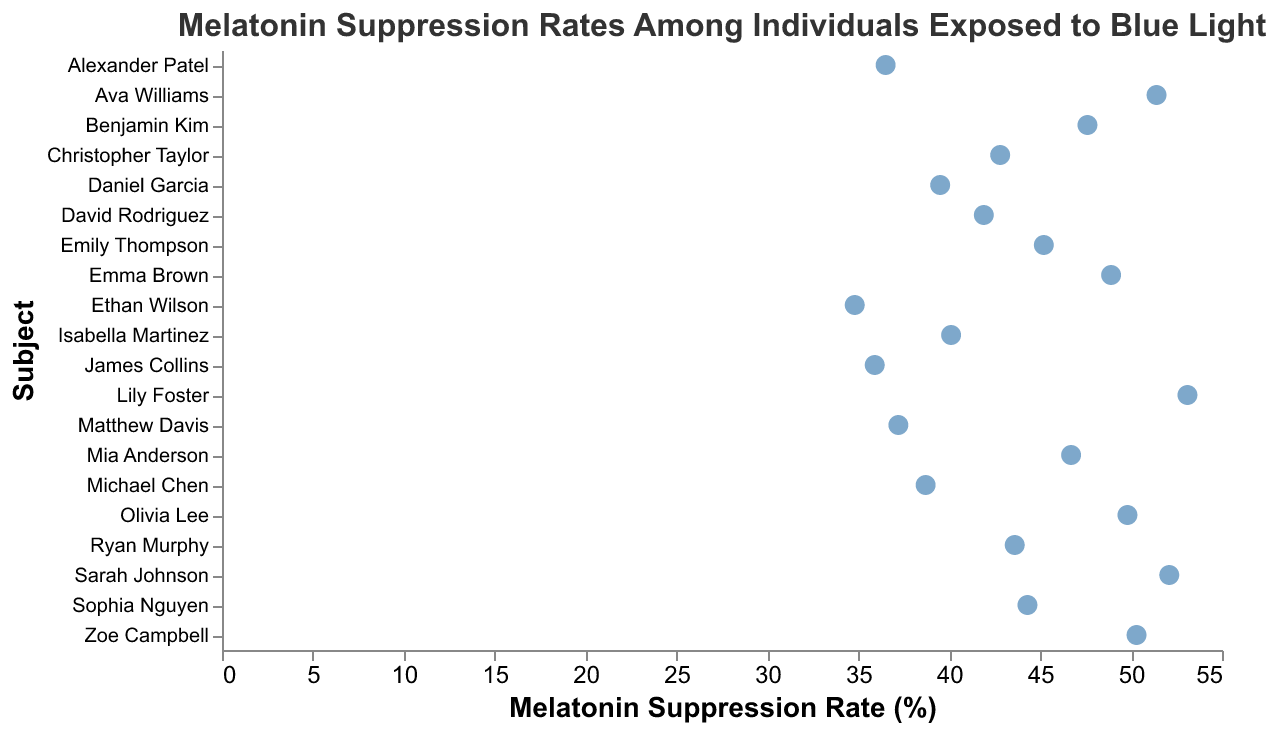Which subject has the highest melatonin suppression rate? Locate the subject with the point farthest to the right on the x-axis. That point corresponds to Lily Foster, with a melatonin suppression rate of 53.1.
Answer: Lily Foster Which subject has the lowest melatonin suppression rate? Locate the subject with the point farthest to the left on the x-axis. That point corresponds to Ethan Wilson, with a melatonin suppression rate of 34.8.
Answer: Ethan Wilson How many subjects are included in the plot? Count each unique point (data entry) on the plot. There are 20 subjects listed in the provided data, and each has a unique data point on the plot.
Answer: 20 What is the average melatonin suppression rate among the subjects? Sum up all the melatonin suppression rates and divide by the number of subjects. The total sum is (45.2 + 38.7 + 52.1 + 41.9 + 49.8 + 36.5 + 44.3 + 47.6 + 40.1 + 34.8 + 51.4 + 39.5 + 46.7 + 42.8 + 48.9 + 37.2 + 50.3 + 43.6 + 53.1 + 35.9) = 880.4. There are 20 subjects, so the average is 880.4 / 20 = 44.02.
Answer: 44.02 What is the range of melatonin suppression rates in the plot? Subtract the lowest suppression rate from the highest. Here, the highest rate is 53.1 (Lily Foster) and the lowest is 34.8 (Ethan Wilson), so the range is 53.1 - 34.8 = 18.3.
Answer: 18.3 Which subjects have melatonin suppression rates above 50%? Identify subjects with points to the right of the 50% mark on the x-axis. These subjects are Sarah Johnson (52.1), Ava Williams (51.4), Zoe Campbell (50.3), and Lily Foster (53.1).
Answer: Sarah Johnson, Ava Williams, Zoe Campbell, Lily Foster How many subjects have a melatonin suppression rate between 40 and 50%? Count the points that fall within the 40-50% range on the x-axis. These subjects are Emily Thompson (45.2), David Rodriguez (41.9), Olivia Lee (49.8), Sophia Nguyen (44.3), Benjamin Kim (47.6), Isabella Martinez (40.1), Mia Anderson (46.7), Christopher Taylor (42.8), Emma Brown (48.9), and Ryan Murphy (43.6). There are 10 subjects in total.
Answer: 10 What is the median value of melatonin suppression rates? Sort all melatonin suppression rates and find the middle value. For 20 subjects, the median is the average of the 10th and 11th values. The sorted rates are (34.8, 35.9, 36.5, 37.2, 38.7, 39.5, 40.1, 41.9, 42.8, 43.6, 44.3, 45.2, 46.7, 47.6, 48.9, 49.8, 50.3, 51.4, 52.1, 53.1). The 10th and 11th values are 43.6 and 44.3; thus, the median is (43.6 + 44.3)/2 = 43.95.
Answer: 43.95 